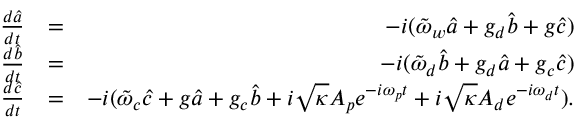Convert formula to latex. <formula><loc_0><loc_0><loc_500><loc_500>\begin{array} { r l r } { \frac { d \hat { a } } { d t } } & { = } & { - i ( \tilde { \omega } _ { w } \hat { a } + g _ { d } \hat { b } + g \hat { c } ) } \\ { \frac { d \hat { b } } { d t } } & { = } & { - i ( \tilde { \omega } _ { d } \hat { b } + g _ { d } \hat { a } + g _ { c } \hat { c } ) } \\ { \frac { d \hat { c } } { d t } } & { = } & { - i ( \tilde { \omega } _ { c } \hat { c } + g \hat { a } + g _ { c } \hat { b } + i \sqrt { \kappa } A _ { p } e ^ { - i \omega _ { p } t } + i \sqrt { \kappa } A _ { d } e ^ { - i \omega _ { d } t } ) . } \end{array}</formula> 